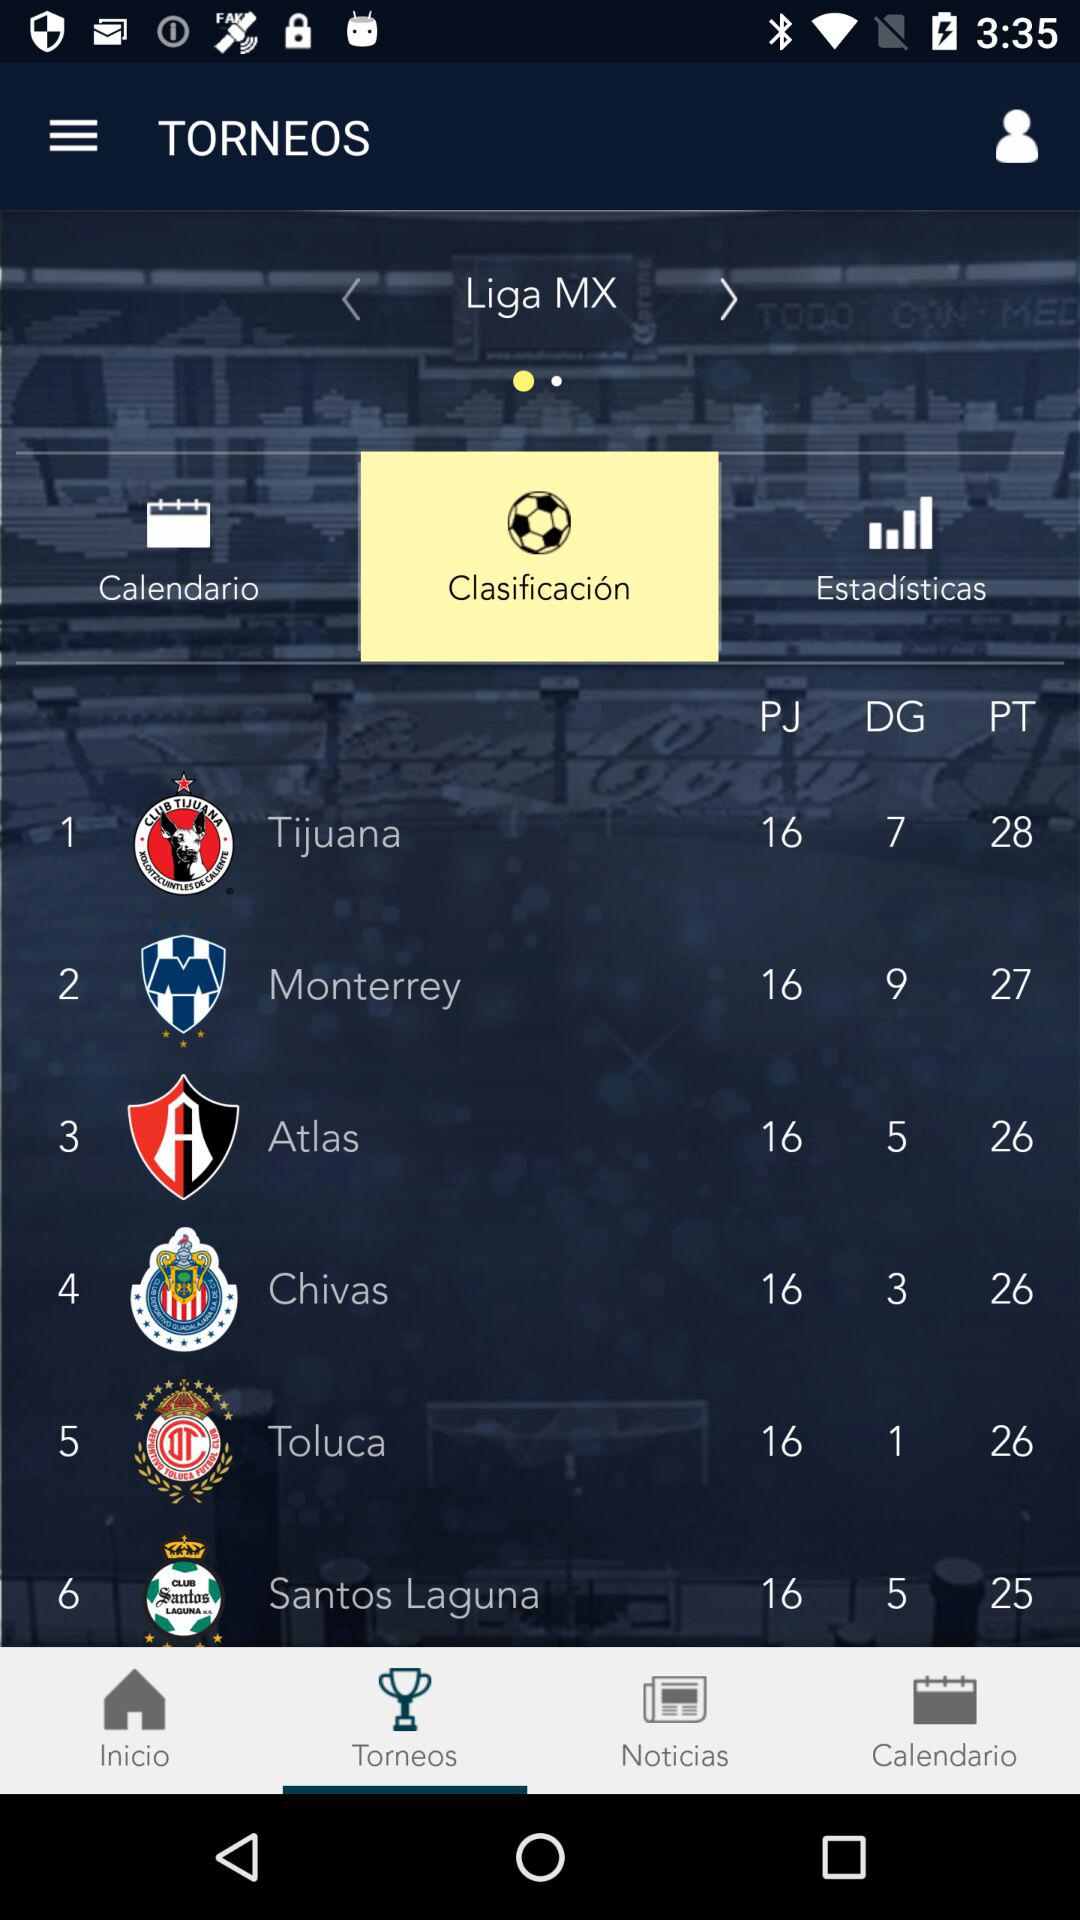Which tab is selected? The selected tabs are "Torneos" and "Clasificación". 